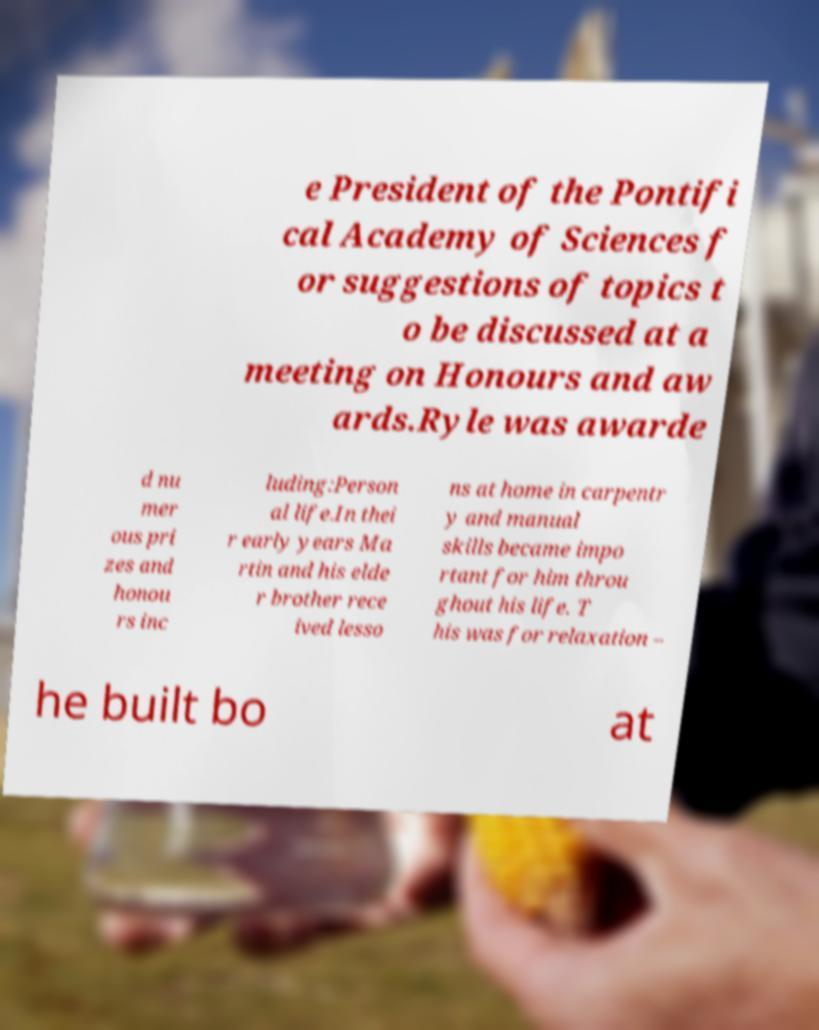Can you read and provide the text displayed in the image?This photo seems to have some interesting text. Can you extract and type it out for me? e President of the Pontifi cal Academy of Sciences f or suggestions of topics t o be discussed at a meeting on Honours and aw ards.Ryle was awarde d nu mer ous pri zes and honou rs inc luding:Person al life.In thei r early years Ma rtin and his elde r brother rece ived lesso ns at home in carpentr y and manual skills became impo rtant for him throu ghout his life. T his was for relaxation – he built bo at 